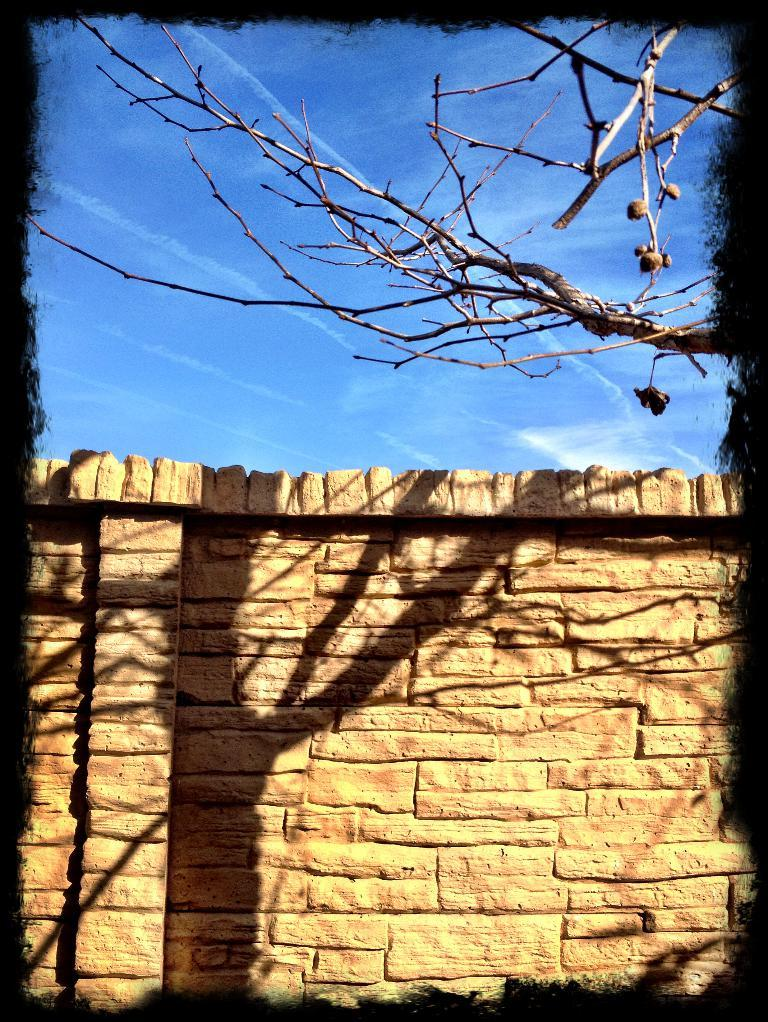What is one of the main features in the image? There is a wall in the image. What natural element can be seen in the image? There is a tree in the image. What can be seen in the distance in the image? The sky is visible in the background of the image. Where is the toothpaste located in the image? There is no toothpaste present in the image. What is the finger doing in the image? There is no finger present in the image. 